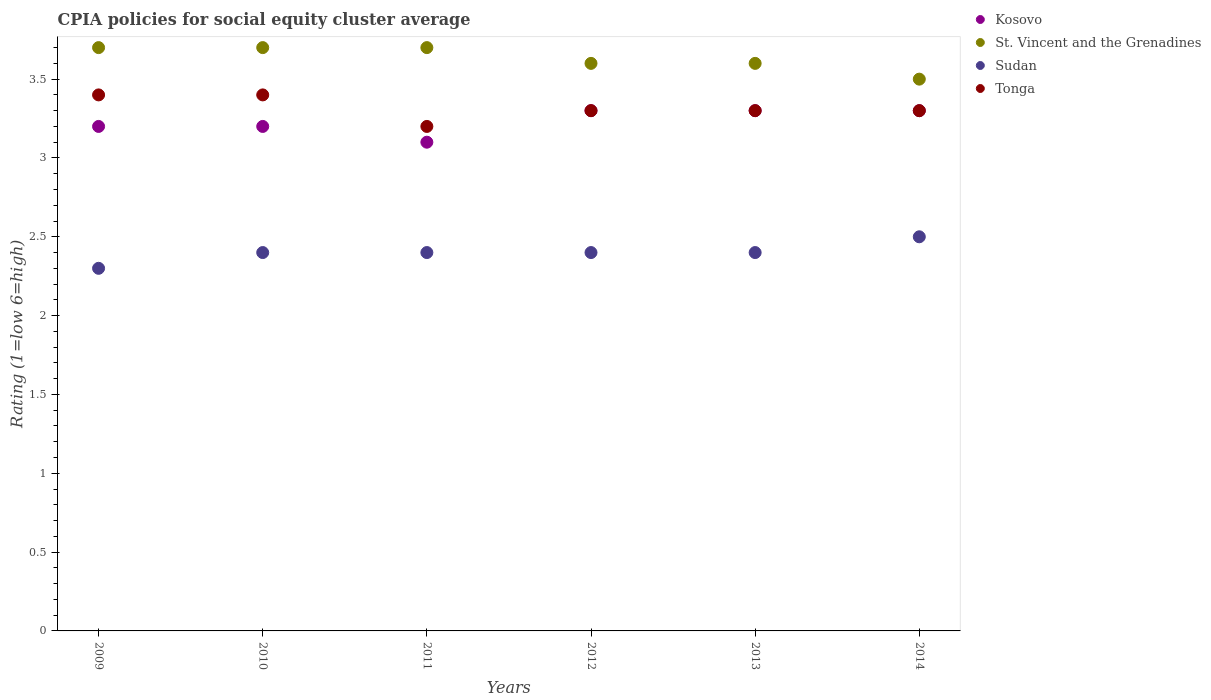Is the number of dotlines equal to the number of legend labels?
Your response must be concise. Yes. Across all years, what is the maximum CPIA rating in St. Vincent and the Grenadines?
Provide a short and direct response. 3.7. Across all years, what is the minimum CPIA rating in St. Vincent and the Grenadines?
Make the answer very short. 3.5. What is the total CPIA rating in Tonga in the graph?
Make the answer very short. 19.9. What is the difference between the CPIA rating in Sudan in 2011 and that in 2014?
Your answer should be very brief. -0.1. What is the difference between the CPIA rating in Tonga in 2009 and the CPIA rating in Sudan in 2010?
Offer a very short reply. 1. What is the average CPIA rating in Tonga per year?
Your answer should be compact. 3.32. In the year 2011, what is the difference between the CPIA rating in Tonga and CPIA rating in Sudan?
Give a very brief answer. 0.8. In how many years, is the CPIA rating in St. Vincent and the Grenadines greater than 2.2?
Provide a short and direct response. 6. What is the difference between the highest and the second highest CPIA rating in Kosovo?
Provide a succinct answer. 0. What is the difference between the highest and the lowest CPIA rating in Sudan?
Provide a short and direct response. 0.2. Is it the case that in every year, the sum of the CPIA rating in St. Vincent and the Grenadines and CPIA rating in Sudan  is greater than the sum of CPIA rating in Tonga and CPIA rating in Kosovo?
Give a very brief answer. Yes. Does the CPIA rating in Kosovo monotonically increase over the years?
Your answer should be very brief. No. Is the CPIA rating in Sudan strictly greater than the CPIA rating in Tonga over the years?
Ensure brevity in your answer.  No. Is the CPIA rating in St. Vincent and the Grenadines strictly less than the CPIA rating in Tonga over the years?
Provide a short and direct response. No. What is the difference between two consecutive major ticks on the Y-axis?
Offer a terse response. 0.5. Does the graph contain any zero values?
Your answer should be very brief. No. Does the graph contain grids?
Your answer should be compact. No. Where does the legend appear in the graph?
Provide a short and direct response. Top right. How are the legend labels stacked?
Provide a short and direct response. Vertical. What is the title of the graph?
Give a very brief answer. CPIA policies for social equity cluster average. What is the Rating (1=low 6=high) of St. Vincent and the Grenadines in 2009?
Your response must be concise. 3.7. What is the Rating (1=low 6=high) in Tonga in 2010?
Make the answer very short. 3.4. What is the Rating (1=low 6=high) of St. Vincent and the Grenadines in 2011?
Keep it short and to the point. 3.7. What is the Rating (1=low 6=high) in Sudan in 2011?
Keep it short and to the point. 2.4. What is the Rating (1=low 6=high) of Kosovo in 2012?
Make the answer very short. 3.3. What is the Rating (1=low 6=high) in Sudan in 2012?
Make the answer very short. 2.4. What is the Rating (1=low 6=high) in St. Vincent and the Grenadines in 2013?
Your answer should be very brief. 3.6. What is the Rating (1=low 6=high) in Tonga in 2013?
Make the answer very short. 3.3. What is the Rating (1=low 6=high) of Kosovo in 2014?
Make the answer very short. 3.3. Across all years, what is the maximum Rating (1=low 6=high) of St. Vincent and the Grenadines?
Provide a succinct answer. 3.7. Across all years, what is the minimum Rating (1=low 6=high) of Kosovo?
Offer a terse response. 3.1. What is the total Rating (1=low 6=high) of Kosovo in the graph?
Ensure brevity in your answer.  19.4. What is the total Rating (1=low 6=high) in St. Vincent and the Grenadines in the graph?
Give a very brief answer. 21.8. What is the total Rating (1=low 6=high) in Tonga in the graph?
Offer a terse response. 19.9. What is the difference between the Rating (1=low 6=high) of Kosovo in 2009 and that in 2010?
Ensure brevity in your answer.  0. What is the difference between the Rating (1=low 6=high) of Tonga in 2009 and that in 2010?
Your answer should be compact. 0. What is the difference between the Rating (1=low 6=high) in Sudan in 2009 and that in 2011?
Your answer should be very brief. -0.1. What is the difference between the Rating (1=low 6=high) in Kosovo in 2009 and that in 2012?
Keep it short and to the point. -0.1. What is the difference between the Rating (1=low 6=high) in Sudan in 2009 and that in 2012?
Provide a short and direct response. -0.1. What is the difference between the Rating (1=low 6=high) of Kosovo in 2009 and that in 2013?
Make the answer very short. -0.1. What is the difference between the Rating (1=low 6=high) of St. Vincent and the Grenadines in 2009 and that in 2013?
Offer a terse response. 0.1. What is the difference between the Rating (1=low 6=high) in Sudan in 2009 and that in 2013?
Keep it short and to the point. -0.1. What is the difference between the Rating (1=low 6=high) of Tonga in 2009 and that in 2013?
Keep it short and to the point. 0.1. What is the difference between the Rating (1=low 6=high) in Sudan in 2009 and that in 2014?
Provide a short and direct response. -0.2. What is the difference between the Rating (1=low 6=high) of Tonga in 2009 and that in 2014?
Provide a succinct answer. 0.1. What is the difference between the Rating (1=low 6=high) of Kosovo in 2010 and that in 2011?
Keep it short and to the point. 0.1. What is the difference between the Rating (1=low 6=high) in St. Vincent and the Grenadines in 2010 and that in 2011?
Your answer should be very brief. 0. What is the difference between the Rating (1=low 6=high) of Sudan in 2010 and that in 2011?
Provide a succinct answer. 0. What is the difference between the Rating (1=low 6=high) in Tonga in 2010 and that in 2011?
Offer a terse response. 0.2. What is the difference between the Rating (1=low 6=high) in Kosovo in 2010 and that in 2012?
Provide a short and direct response. -0.1. What is the difference between the Rating (1=low 6=high) of Sudan in 2010 and that in 2012?
Give a very brief answer. 0. What is the difference between the Rating (1=low 6=high) in Tonga in 2010 and that in 2012?
Offer a terse response. 0.1. What is the difference between the Rating (1=low 6=high) in Kosovo in 2010 and that in 2013?
Provide a succinct answer. -0.1. What is the difference between the Rating (1=low 6=high) in Tonga in 2010 and that in 2013?
Provide a short and direct response. 0.1. What is the difference between the Rating (1=low 6=high) in Kosovo in 2010 and that in 2014?
Your answer should be very brief. -0.1. What is the difference between the Rating (1=low 6=high) in Tonga in 2010 and that in 2014?
Give a very brief answer. 0.1. What is the difference between the Rating (1=low 6=high) in Kosovo in 2011 and that in 2012?
Give a very brief answer. -0.2. What is the difference between the Rating (1=low 6=high) in St. Vincent and the Grenadines in 2011 and that in 2012?
Give a very brief answer. 0.1. What is the difference between the Rating (1=low 6=high) of Sudan in 2011 and that in 2012?
Provide a short and direct response. 0. What is the difference between the Rating (1=low 6=high) of Tonga in 2011 and that in 2012?
Your response must be concise. -0.1. What is the difference between the Rating (1=low 6=high) of Kosovo in 2011 and that in 2013?
Your answer should be compact. -0.2. What is the difference between the Rating (1=low 6=high) in St. Vincent and the Grenadines in 2011 and that in 2013?
Your answer should be compact. 0.1. What is the difference between the Rating (1=low 6=high) in St. Vincent and the Grenadines in 2011 and that in 2014?
Offer a very short reply. 0.2. What is the difference between the Rating (1=low 6=high) in Kosovo in 2012 and that in 2013?
Your answer should be compact. 0. What is the difference between the Rating (1=low 6=high) of St. Vincent and the Grenadines in 2012 and that in 2013?
Provide a short and direct response. 0. What is the difference between the Rating (1=low 6=high) of Tonga in 2012 and that in 2013?
Offer a terse response. 0. What is the difference between the Rating (1=low 6=high) in Kosovo in 2012 and that in 2014?
Your response must be concise. 0. What is the difference between the Rating (1=low 6=high) in St. Vincent and the Grenadines in 2012 and that in 2014?
Ensure brevity in your answer.  0.1. What is the difference between the Rating (1=low 6=high) in St. Vincent and the Grenadines in 2013 and that in 2014?
Your answer should be very brief. 0.1. What is the difference between the Rating (1=low 6=high) of Kosovo in 2009 and the Rating (1=low 6=high) of St. Vincent and the Grenadines in 2010?
Provide a succinct answer. -0.5. What is the difference between the Rating (1=low 6=high) of Kosovo in 2009 and the Rating (1=low 6=high) of Sudan in 2010?
Your answer should be compact. 0.8. What is the difference between the Rating (1=low 6=high) in Kosovo in 2009 and the Rating (1=low 6=high) in Tonga in 2010?
Your response must be concise. -0.2. What is the difference between the Rating (1=low 6=high) of Sudan in 2009 and the Rating (1=low 6=high) of Tonga in 2010?
Offer a very short reply. -1.1. What is the difference between the Rating (1=low 6=high) of Kosovo in 2009 and the Rating (1=low 6=high) of Sudan in 2011?
Your answer should be very brief. 0.8. What is the difference between the Rating (1=low 6=high) of St. Vincent and the Grenadines in 2009 and the Rating (1=low 6=high) of Sudan in 2011?
Offer a terse response. 1.3. What is the difference between the Rating (1=low 6=high) in St. Vincent and the Grenadines in 2009 and the Rating (1=low 6=high) in Tonga in 2011?
Provide a succinct answer. 0.5. What is the difference between the Rating (1=low 6=high) of Sudan in 2009 and the Rating (1=low 6=high) of Tonga in 2011?
Your answer should be very brief. -0.9. What is the difference between the Rating (1=low 6=high) in Kosovo in 2009 and the Rating (1=low 6=high) in Tonga in 2012?
Keep it short and to the point. -0.1. What is the difference between the Rating (1=low 6=high) in St. Vincent and the Grenadines in 2009 and the Rating (1=low 6=high) in Sudan in 2012?
Your answer should be compact. 1.3. What is the difference between the Rating (1=low 6=high) of St. Vincent and the Grenadines in 2009 and the Rating (1=low 6=high) of Tonga in 2012?
Ensure brevity in your answer.  0.4. What is the difference between the Rating (1=low 6=high) of Kosovo in 2009 and the Rating (1=low 6=high) of Tonga in 2013?
Ensure brevity in your answer.  -0.1. What is the difference between the Rating (1=low 6=high) in St. Vincent and the Grenadines in 2009 and the Rating (1=low 6=high) in Sudan in 2013?
Your answer should be very brief. 1.3. What is the difference between the Rating (1=low 6=high) in St. Vincent and the Grenadines in 2009 and the Rating (1=low 6=high) in Tonga in 2013?
Keep it short and to the point. 0.4. What is the difference between the Rating (1=low 6=high) in Kosovo in 2009 and the Rating (1=low 6=high) in Tonga in 2014?
Offer a terse response. -0.1. What is the difference between the Rating (1=low 6=high) of St. Vincent and the Grenadines in 2009 and the Rating (1=low 6=high) of Tonga in 2014?
Give a very brief answer. 0.4. What is the difference between the Rating (1=low 6=high) in Kosovo in 2010 and the Rating (1=low 6=high) in St. Vincent and the Grenadines in 2011?
Keep it short and to the point. -0.5. What is the difference between the Rating (1=low 6=high) in Kosovo in 2010 and the Rating (1=low 6=high) in Sudan in 2011?
Give a very brief answer. 0.8. What is the difference between the Rating (1=low 6=high) of Kosovo in 2010 and the Rating (1=low 6=high) of Tonga in 2011?
Your response must be concise. 0. What is the difference between the Rating (1=low 6=high) in St. Vincent and the Grenadines in 2010 and the Rating (1=low 6=high) in Tonga in 2011?
Your answer should be compact. 0.5. What is the difference between the Rating (1=low 6=high) of Kosovo in 2010 and the Rating (1=low 6=high) of Sudan in 2012?
Your response must be concise. 0.8. What is the difference between the Rating (1=low 6=high) in Kosovo in 2010 and the Rating (1=low 6=high) in Tonga in 2012?
Provide a succinct answer. -0.1. What is the difference between the Rating (1=low 6=high) in Kosovo in 2010 and the Rating (1=low 6=high) in St. Vincent and the Grenadines in 2013?
Offer a terse response. -0.4. What is the difference between the Rating (1=low 6=high) in Kosovo in 2010 and the Rating (1=low 6=high) in Sudan in 2013?
Your response must be concise. 0.8. What is the difference between the Rating (1=low 6=high) in St. Vincent and the Grenadines in 2010 and the Rating (1=low 6=high) in Sudan in 2013?
Provide a succinct answer. 1.3. What is the difference between the Rating (1=low 6=high) of Kosovo in 2010 and the Rating (1=low 6=high) of St. Vincent and the Grenadines in 2014?
Your answer should be very brief. -0.3. What is the difference between the Rating (1=low 6=high) of St. Vincent and the Grenadines in 2010 and the Rating (1=low 6=high) of Sudan in 2014?
Offer a very short reply. 1.2. What is the difference between the Rating (1=low 6=high) in Kosovo in 2011 and the Rating (1=low 6=high) in St. Vincent and the Grenadines in 2012?
Offer a very short reply. -0.5. What is the difference between the Rating (1=low 6=high) in Kosovo in 2011 and the Rating (1=low 6=high) in Sudan in 2012?
Offer a very short reply. 0.7. What is the difference between the Rating (1=low 6=high) in Kosovo in 2011 and the Rating (1=low 6=high) in Tonga in 2012?
Ensure brevity in your answer.  -0.2. What is the difference between the Rating (1=low 6=high) in St. Vincent and the Grenadines in 2011 and the Rating (1=low 6=high) in Sudan in 2014?
Make the answer very short. 1.2. What is the difference between the Rating (1=low 6=high) in Sudan in 2011 and the Rating (1=low 6=high) in Tonga in 2014?
Your answer should be compact. -0.9. What is the difference between the Rating (1=low 6=high) in Kosovo in 2012 and the Rating (1=low 6=high) in Sudan in 2013?
Ensure brevity in your answer.  0.9. What is the difference between the Rating (1=low 6=high) in Kosovo in 2012 and the Rating (1=low 6=high) in Tonga in 2013?
Your response must be concise. 0. What is the difference between the Rating (1=low 6=high) in St. Vincent and the Grenadines in 2012 and the Rating (1=low 6=high) in Sudan in 2013?
Ensure brevity in your answer.  1.2. What is the difference between the Rating (1=low 6=high) in Kosovo in 2012 and the Rating (1=low 6=high) in Tonga in 2014?
Give a very brief answer. 0. What is the difference between the Rating (1=low 6=high) in St. Vincent and the Grenadines in 2012 and the Rating (1=low 6=high) in Sudan in 2014?
Offer a very short reply. 1.1. What is the difference between the Rating (1=low 6=high) of St. Vincent and the Grenadines in 2012 and the Rating (1=low 6=high) of Tonga in 2014?
Offer a very short reply. 0.3. What is the difference between the Rating (1=low 6=high) of Sudan in 2012 and the Rating (1=low 6=high) of Tonga in 2014?
Give a very brief answer. -0.9. What is the difference between the Rating (1=low 6=high) of Kosovo in 2013 and the Rating (1=low 6=high) of St. Vincent and the Grenadines in 2014?
Ensure brevity in your answer.  -0.2. What is the difference between the Rating (1=low 6=high) of Kosovo in 2013 and the Rating (1=low 6=high) of Sudan in 2014?
Offer a very short reply. 0.8. What is the difference between the Rating (1=low 6=high) in Kosovo in 2013 and the Rating (1=low 6=high) in Tonga in 2014?
Offer a terse response. 0. What is the difference between the Rating (1=low 6=high) in St. Vincent and the Grenadines in 2013 and the Rating (1=low 6=high) in Sudan in 2014?
Give a very brief answer. 1.1. What is the difference between the Rating (1=low 6=high) in Sudan in 2013 and the Rating (1=low 6=high) in Tonga in 2014?
Provide a succinct answer. -0.9. What is the average Rating (1=low 6=high) of Kosovo per year?
Ensure brevity in your answer.  3.23. What is the average Rating (1=low 6=high) of St. Vincent and the Grenadines per year?
Your answer should be compact. 3.63. What is the average Rating (1=low 6=high) in Sudan per year?
Your response must be concise. 2.4. What is the average Rating (1=low 6=high) of Tonga per year?
Provide a short and direct response. 3.32. In the year 2009, what is the difference between the Rating (1=low 6=high) in Kosovo and Rating (1=low 6=high) in Sudan?
Offer a very short reply. 0.9. In the year 2009, what is the difference between the Rating (1=low 6=high) in St. Vincent and the Grenadines and Rating (1=low 6=high) in Tonga?
Your response must be concise. 0.3. In the year 2010, what is the difference between the Rating (1=low 6=high) in Kosovo and Rating (1=low 6=high) in Tonga?
Offer a very short reply. -0.2. In the year 2010, what is the difference between the Rating (1=low 6=high) of St. Vincent and the Grenadines and Rating (1=low 6=high) of Sudan?
Ensure brevity in your answer.  1.3. In the year 2010, what is the difference between the Rating (1=low 6=high) in St. Vincent and the Grenadines and Rating (1=low 6=high) in Tonga?
Your response must be concise. 0.3. In the year 2010, what is the difference between the Rating (1=low 6=high) of Sudan and Rating (1=low 6=high) of Tonga?
Provide a short and direct response. -1. In the year 2011, what is the difference between the Rating (1=low 6=high) in Kosovo and Rating (1=low 6=high) in St. Vincent and the Grenadines?
Your answer should be compact. -0.6. In the year 2011, what is the difference between the Rating (1=low 6=high) of Kosovo and Rating (1=low 6=high) of Sudan?
Give a very brief answer. 0.7. In the year 2011, what is the difference between the Rating (1=low 6=high) in Kosovo and Rating (1=low 6=high) in Tonga?
Offer a very short reply. -0.1. In the year 2011, what is the difference between the Rating (1=low 6=high) in St. Vincent and the Grenadines and Rating (1=low 6=high) in Sudan?
Your response must be concise. 1.3. In the year 2011, what is the difference between the Rating (1=low 6=high) in St. Vincent and the Grenadines and Rating (1=low 6=high) in Tonga?
Offer a terse response. 0.5. In the year 2011, what is the difference between the Rating (1=low 6=high) of Sudan and Rating (1=low 6=high) of Tonga?
Make the answer very short. -0.8. In the year 2012, what is the difference between the Rating (1=low 6=high) of Kosovo and Rating (1=low 6=high) of St. Vincent and the Grenadines?
Your response must be concise. -0.3. In the year 2012, what is the difference between the Rating (1=low 6=high) of Kosovo and Rating (1=low 6=high) of Tonga?
Your response must be concise. 0. In the year 2013, what is the difference between the Rating (1=low 6=high) in Kosovo and Rating (1=low 6=high) in Sudan?
Make the answer very short. 0.9. In the year 2013, what is the difference between the Rating (1=low 6=high) in Kosovo and Rating (1=low 6=high) in Tonga?
Offer a very short reply. 0. In the year 2013, what is the difference between the Rating (1=low 6=high) in St. Vincent and the Grenadines and Rating (1=low 6=high) in Tonga?
Your answer should be compact. 0.3. In the year 2013, what is the difference between the Rating (1=low 6=high) of Sudan and Rating (1=low 6=high) of Tonga?
Provide a succinct answer. -0.9. In the year 2014, what is the difference between the Rating (1=low 6=high) in Kosovo and Rating (1=low 6=high) in St. Vincent and the Grenadines?
Provide a succinct answer. -0.2. In the year 2014, what is the difference between the Rating (1=low 6=high) of St. Vincent and the Grenadines and Rating (1=low 6=high) of Tonga?
Give a very brief answer. 0.2. In the year 2014, what is the difference between the Rating (1=low 6=high) of Sudan and Rating (1=low 6=high) of Tonga?
Provide a short and direct response. -0.8. What is the ratio of the Rating (1=low 6=high) in St. Vincent and the Grenadines in 2009 to that in 2010?
Ensure brevity in your answer.  1. What is the ratio of the Rating (1=low 6=high) in Sudan in 2009 to that in 2010?
Give a very brief answer. 0.96. What is the ratio of the Rating (1=low 6=high) in Tonga in 2009 to that in 2010?
Your answer should be very brief. 1. What is the ratio of the Rating (1=low 6=high) in Kosovo in 2009 to that in 2011?
Provide a succinct answer. 1.03. What is the ratio of the Rating (1=low 6=high) in Kosovo in 2009 to that in 2012?
Your answer should be compact. 0.97. What is the ratio of the Rating (1=low 6=high) in St. Vincent and the Grenadines in 2009 to that in 2012?
Offer a very short reply. 1.03. What is the ratio of the Rating (1=low 6=high) of Tonga in 2009 to that in 2012?
Offer a terse response. 1.03. What is the ratio of the Rating (1=low 6=high) of Kosovo in 2009 to that in 2013?
Provide a short and direct response. 0.97. What is the ratio of the Rating (1=low 6=high) of St. Vincent and the Grenadines in 2009 to that in 2013?
Your answer should be compact. 1.03. What is the ratio of the Rating (1=low 6=high) in Sudan in 2009 to that in 2013?
Your answer should be very brief. 0.96. What is the ratio of the Rating (1=low 6=high) of Tonga in 2009 to that in 2013?
Offer a terse response. 1.03. What is the ratio of the Rating (1=low 6=high) in Kosovo in 2009 to that in 2014?
Offer a very short reply. 0.97. What is the ratio of the Rating (1=low 6=high) in St. Vincent and the Grenadines in 2009 to that in 2014?
Your answer should be compact. 1.06. What is the ratio of the Rating (1=low 6=high) of Sudan in 2009 to that in 2014?
Your answer should be compact. 0.92. What is the ratio of the Rating (1=low 6=high) in Tonga in 2009 to that in 2014?
Your response must be concise. 1.03. What is the ratio of the Rating (1=low 6=high) of Kosovo in 2010 to that in 2011?
Your answer should be compact. 1.03. What is the ratio of the Rating (1=low 6=high) of St. Vincent and the Grenadines in 2010 to that in 2011?
Make the answer very short. 1. What is the ratio of the Rating (1=low 6=high) of Kosovo in 2010 to that in 2012?
Make the answer very short. 0.97. What is the ratio of the Rating (1=low 6=high) in St. Vincent and the Grenadines in 2010 to that in 2012?
Give a very brief answer. 1.03. What is the ratio of the Rating (1=low 6=high) in Sudan in 2010 to that in 2012?
Keep it short and to the point. 1. What is the ratio of the Rating (1=low 6=high) in Tonga in 2010 to that in 2012?
Your response must be concise. 1.03. What is the ratio of the Rating (1=low 6=high) in Kosovo in 2010 to that in 2013?
Your answer should be very brief. 0.97. What is the ratio of the Rating (1=low 6=high) of St. Vincent and the Grenadines in 2010 to that in 2013?
Your answer should be very brief. 1.03. What is the ratio of the Rating (1=low 6=high) in Tonga in 2010 to that in 2013?
Make the answer very short. 1.03. What is the ratio of the Rating (1=low 6=high) of Kosovo in 2010 to that in 2014?
Keep it short and to the point. 0.97. What is the ratio of the Rating (1=low 6=high) of St. Vincent and the Grenadines in 2010 to that in 2014?
Offer a very short reply. 1.06. What is the ratio of the Rating (1=low 6=high) of Tonga in 2010 to that in 2014?
Your answer should be very brief. 1.03. What is the ratio of the Rating (1=low 6=high) in Kosovo in 2011 to that in 2012?
Make the answer very short. 0.94. What is the ratio of the Rating (1=low 6=high) in St. Vincent and the Grenadines in 2011 to that in 2012?
Give a very brief answer. 1.03. What is the ratio of the Rating (1=low 6=high) in Sudan in 2011 to that in 2012?
Give a very brief answer. 1. What is the ratio of the Rating (1=low 6=high) in Tonga in 2011 to that in 2012?
Offer a terse response. 0.97. What is the ratio of the Rating (1=low 6=high) of Kosovo in 2011 to that in 2013?
Ensure brevity in your answer.  0.94. What is the ratio of the Rating (1=low 6=high) of St. Vincent and the Grenadines in 2011 to that in 2013?
Provide a short and direct response. 1.03. What is the ratio of the Rating (1=low 6=high) of Sudan in 2011 to that in 2013?
Your answer should be very brief. 1. What is the ratio of the Rating (1=low 6=high) in Tonga in 2011 to that in 2013?
Your answer should be very brief. 0.97. What is the ratio of the Rating (1=low 6=high) in Kosovo in 2011 to that in 2014?
Ensure brevity in your answer.  0.94. What is the ratio of the Rating (1=low 6=high) in St. Vincent and the Grenadines in 2011 to that in 2014?
Your answer should be very brief. 1.06. What is the ratio of the Rating (1=low 6=high) of Sudan in 2011 to that in 2014?
Your response must be concise. 0.96. What is the ratio of the Rating (1=low 6=high) in Tonga in 2011 to that in 2014?
Make the answer very short. 0.97. What is the ratio of the Rating (1=low 6=high) of Kosovo in 2012 to that in 2013?
Keep it short and to the point. 1. What is the ratio of the Rating (1=low 6=high) of Kosovo in 2012 to that in 2014?
Your response must be concise. 1. What is the ratio of the Rating (1=low 6=high) in St. Vincent and the Grenadines in 2012 to that in 2014?
Provide a succinct answer. 1.03. What is the ratio of the Rating (1=low 6=high) of Kosovo in 2013 to that in 2014?
Ensure brevity in your answer.  1. What is the ratio of the Rating (1=low 6=high) of St. Vincent and the Grenadines in 2013 to that in 2014?
Offer a very short reply. 1.03. What is the difference between the highest and the second highest Rating (1=low 6=high) of Sudan?
Your response must be concise. 0.1. What is the difference between the highest and the lowest Rating (1=low 6=high) in Kosovo?
Ensure brevity in your answer.  0.2. What is the difference between the highest and the lowest Rating (1=low 6=high) in St. Vincent and the Grenadines?
Ensure brevity in your answer.  0.2. What is the difference between the highest and the lowest Rating (1=low 6=high) of Sudan?
Offer a terse response. 0.2. What is the difference between the highest and the lowest Rating (1=low 6=high) in Tonga?
Your answer should be compact. 0.2. 